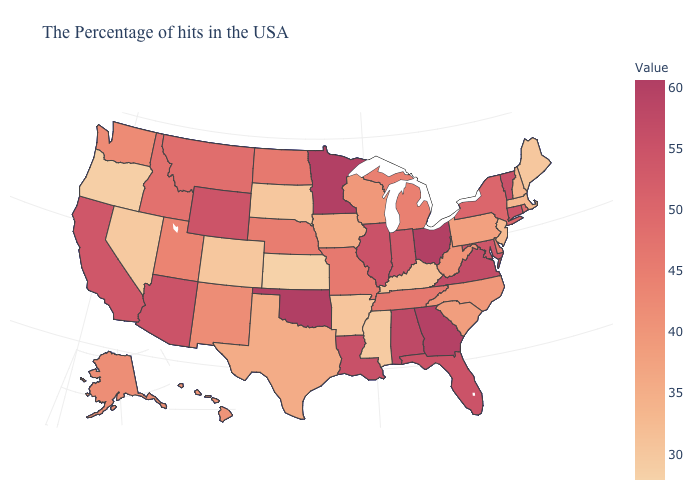Does North Dakota have a higher value than New York?
Be succinct. No. Does Idaho have the lowest value in the West?
Short answer required. No. Among the states that border Iowa , does Minnesota have the highest value?
Answer briefly. Yes. Does Oklahoma have the highest value in the South?
Be succinct. Yes. Which states have the highest value in the USA?
Be succinct. Oklahoma. 